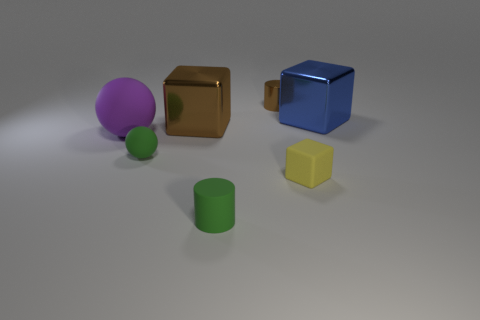Subtract all blue metallic blocks. How many blocks are left? 2 Add 2 yellow rubber cylinders. How many objects exist? 9 Subtract all yellow cubes. How many cubes are left? 2 Subtract all balls. How many objects are left? 5 Subtract 1 green balls. How many objects are left? 6 Subtract all brown cubes. Subtract all brown spheres. How many cubes are left? 2 Subtract all tiny gray rubber spheres. Subtract all tiny brown metal objects. How many objects are left? 6 Add 2 rubber cylinders. How many rubber cylinders are left? 3 Add 4 big green objects. How many big green objects exist? 4 